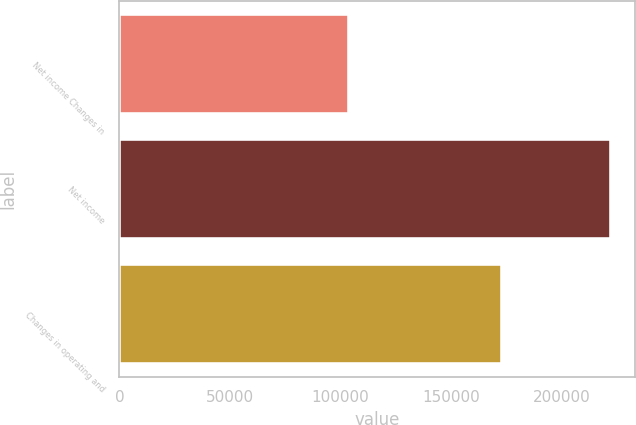Convert chart to OTSL. <chart><loc_0><loc_0><loc_500><loc_500><bar_chart><fcel>Net income Changes in<fcel>Net income<fcel>Changes in operating and<nl><fcel>104043<fcel>222254<fcel>173238<nl></chart> 